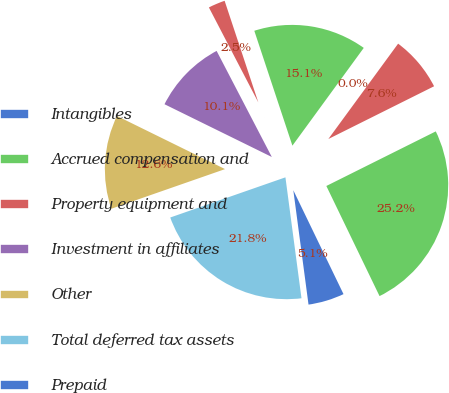Convert chart. <chart><loc_0><loc_0><loc_500><loc_500><pie_chart><fcel>Intangibles<fcel>Accrued compensation and<fcel>Property equipment and<fcel>Investment in affiliates<fcel>Other<fcel>Total deferred tax assets<fcel>Prepaid<fcel>Total deferred tax liabilities<fcel>Net deferred tax liabilities<nl><fcel>0.02%<fcel>15.13%<fcel>2.54%<fcel>10.09%<fcel>12.61%<fcel>21.76%<fcel>5.06%<fcel>25.2%<fcel>7.58%<nl></chart> 